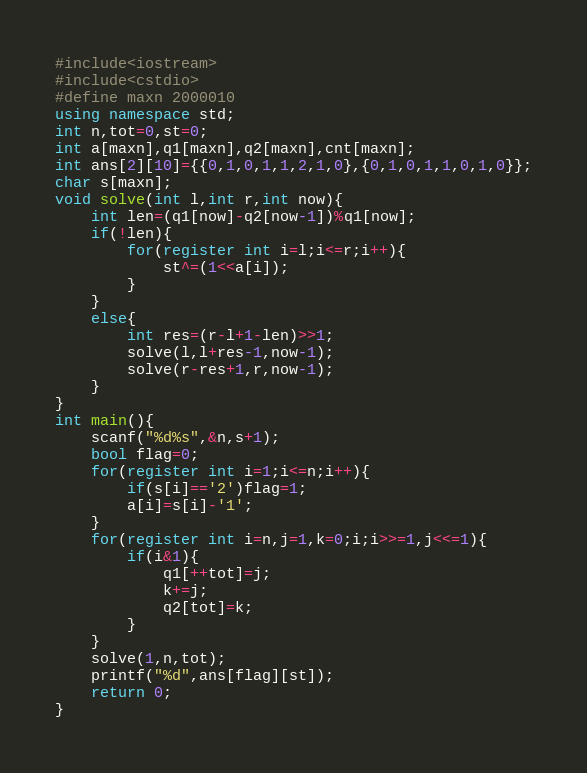Convert code to text. <code><loc_0><loc_0><loc_500><loc_500><_C++_>#include<iostream>
#include<cstdio>
#define maxn 2000010
using namespace std;
int n,tot=0,st=0;
int a[maxn],q1[maxn],q2[maxn],cnt[maxn];
int ans[2][10]={{0,1,0,1,1,2,1,0},{0,1,0,1,1,0,1,0}};
char s[maxn];
void solve(int l,int r,int now){
	int len=(q1[now]-q2[now-1])%q1[now];
	if(!len){
		for(register int i=l;i<=r;i++){
			st^=(1<<a[i]);
		}
	}
	else{
		int res=(r-l+1-len)>>1;
		solve(l,l+res-1,now-1);
		solve(r-res+1,r,now-1);
	}
}
int main(){
	scanf("%d%s",&n,s+1);
	bool flag=0; 
	for(register int i=1;i<=n;i++){
		if(s[i]=='2')flag=1;
		a[i]=s[i]-'1';
	}
	for(register int i=n,j=1,k=0;i;i>>=1,j<<=1){
		if(i&1){
			q1[++tot]=j;
			k+=j;
			q2[tot]=k;
		}
	}
	solve(1,n,tot);
	printf("%d",ans[flag][st]);
	return 0;
} </code> 